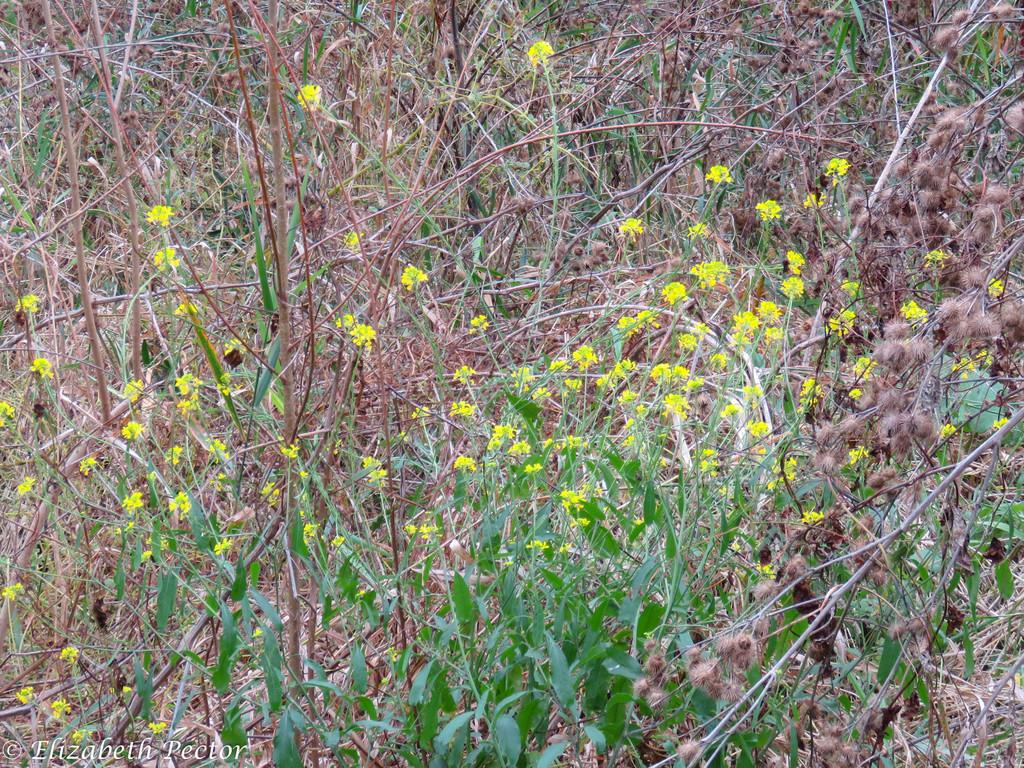What type of vegetation can be seen in the image? There are flowers, plants, and grass in the image. Can you describe the different types of vegetation present? The image contains flowers, which are typically colorful and fragrant, plants, which are larger and more varied in appearance, and grass, which is a type of plant that grows low to the ground. What is the setting of the image? The image features a natural environment, as indicated by the presence of flowers, plants, and grass. What type of linen is being used to cover the selection of reaction in the image? There is no linen or selection of reactions present in the image; it features flowers, plants, and grass in a natural setting. 